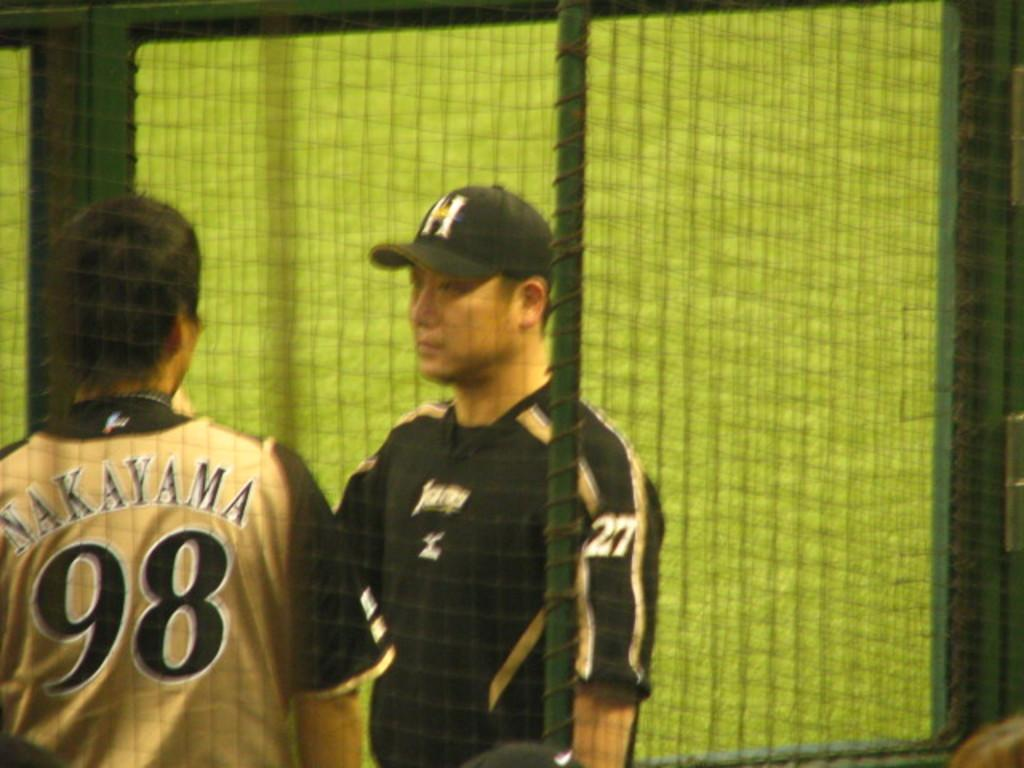<image>
Create a compact narrative representing the image presented. a player with the number 98 on their jersey 